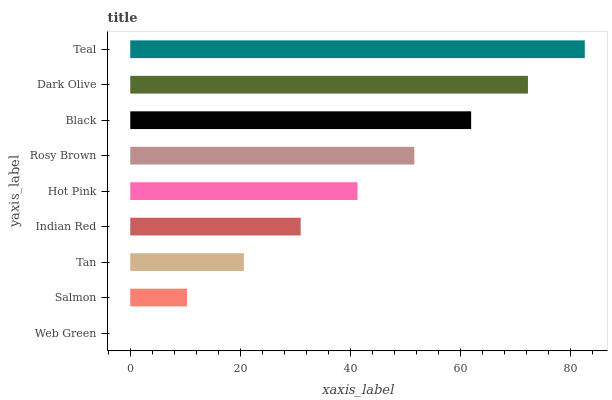Is Web Green the minimum?
Answer yes or no. Yes. Is Teal the maximum?
Answer yes or no. Yes. Is Salmon the minimum?
Answer yes or no. No. Is Salmon the maximum?
Answer yes or no. No. Is Salmon greater than Web Green?
Answer yes or no. Yes. Is Web Green less than Salmon?
Answer yes or no. Yes. Is Web Green greater than Salmon?
Answer yes or no. No. Is Salmon less than Web Green?
Answer yes or no. No. Is Hot Pink the high median?
Answer yes or no. Yes. Is Hot Pink the low median?
Answer yes or no. Yes. Is Black the high median?
Answer yes or no. No. Is Tan the low median?
Answer yes or no. No. 